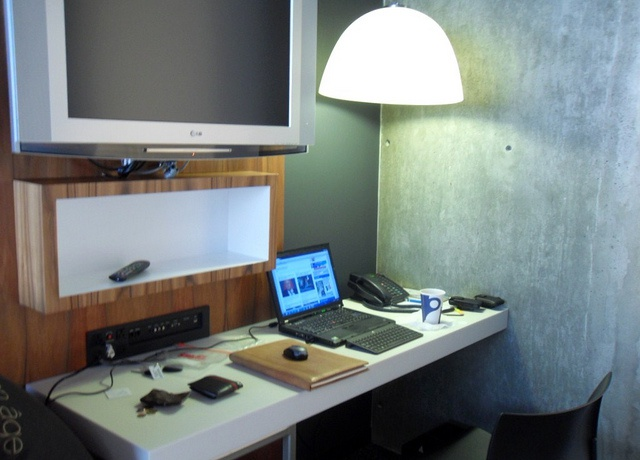Describe the objects in this image and their specific colors. I can see tv in black, gray, darkgray, and lightgray tones, laptop in black, gray, and lightblue tones, chair in black, blue, and darkblue tones, book in black, tan, gray, and olive tones, and keyboard in black and gray tones in this image. 